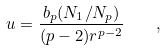<formula> <loc_0><loc_0><loc_500><loc_500>u = { \frac { b _ { p } ( N _ { 1 } / N _ { p } ) } { ( p - 2 ) r ^ { p - 2 } } } \quad ,</formula> 